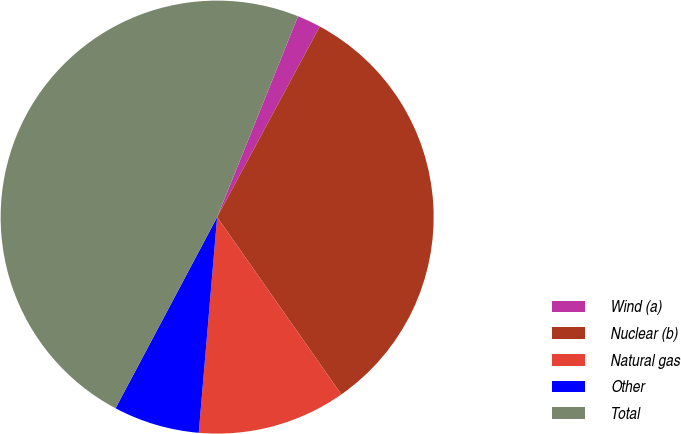Convert chart. <chart><loc_0><loc_0><loc_500><loc_500><pie_chart><fcel>Wind (a)<fcel>Nuclear (b)<fcel>Natural gas<fcel>Other<fcel>Total<nl><fcel>1.77%<fcel>32.41%<fcel>11.08%<fcel>6.42%<fcel>48.32%<nl></chart> 